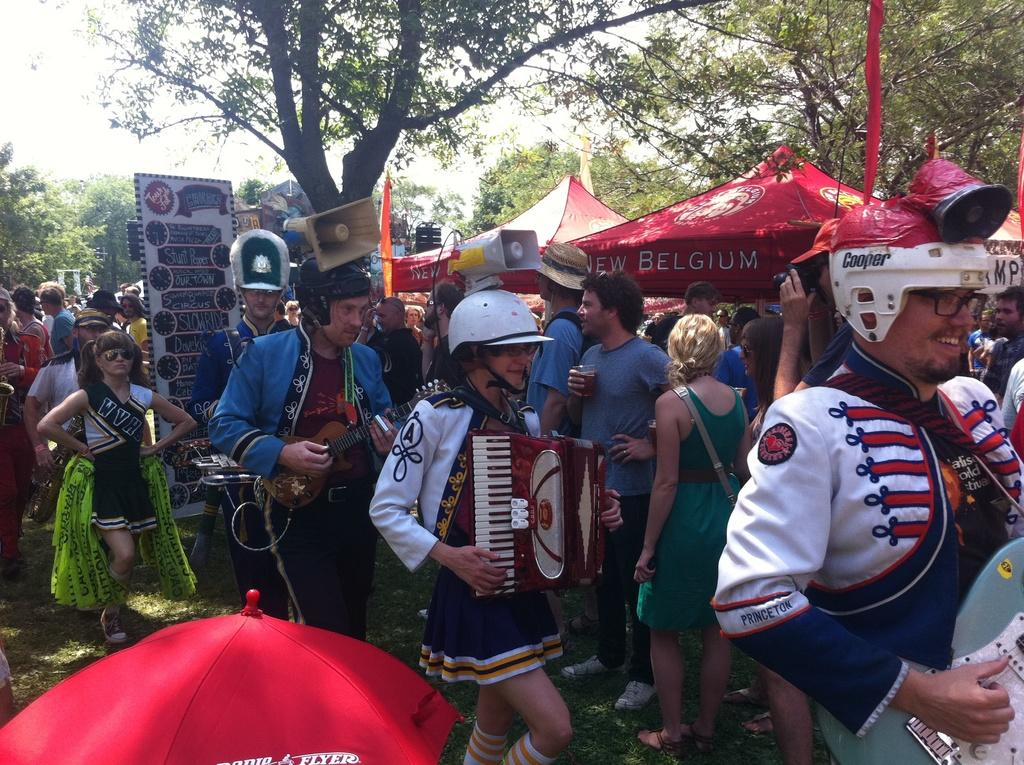How many people are playing musical instruments in the image? There are three people playing musical instruments in the image. What objects are present in the image that are related to sound? There are speakers in the image. What is the board used for in the image? The purpose of the board in the image is not specified, but it could be used for displaying information or as a prop. What is the umbrella being used for in the image? The purpose of the umbrella in the image is not specified, but it could be used for shade or as a decorative element. What type of shelter is visible in the image? There are tents in the image. What type of ground surface is visible in the image? There is grass in the image. What can be seen in the background of the image? There are trees and the sky visible in the background of the image. What book is the person reading in the image? There is no person reading a book in the image. How can you help the person playing the guitar in the image? There is no need to help the person playing the guitar in the image, as they are already playing their instrument. 